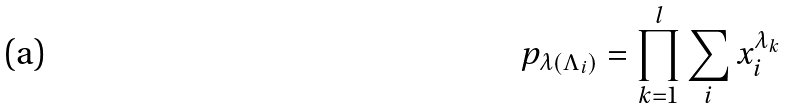<formula> <loc_0><loc_0><loc_500><loc_500>p _ { \lambda ( \Lambda _ { i } ) } = \prod _ { k = 1 } ^ { l } \sum _ { i } x _ { i } ^ { \lambda _ { k } }</formula> 